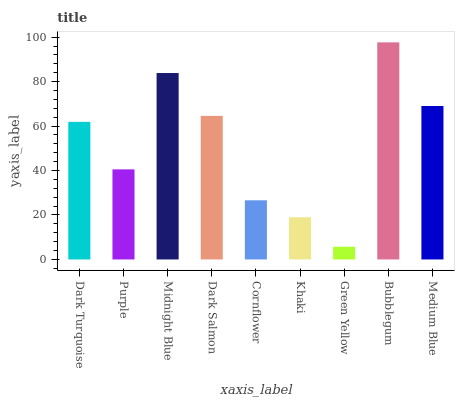Is Green Yellow the minimum?
Answer yes or no. Yes. Is Bubblegum the maximum?
Answer yes or no. Yes. Is Purple the minimum?
Answer yes or no. No. Is Purple the maximum?
Answer yes or no. No. Is Dark Turquoise greater than Purple?
Answer yes or no. Yes. Is Purple less than Dark Turquoise?
Answer yes or no. Yes. Is Purple greater than Dark Turquoise?
Answer yes or no. No. Is Dark Turquoise less than Purple?
Answer yes or no. No. Is Dark Turquoise the high median?
Answer yes or no. Yes. Is Dark Turquoise the low median?
Answer yes or no. Yes. Is Dark Salmon the high median?
Answer yes or no. No. Is Medium Blue the low median?
Answer yes or no. No. 